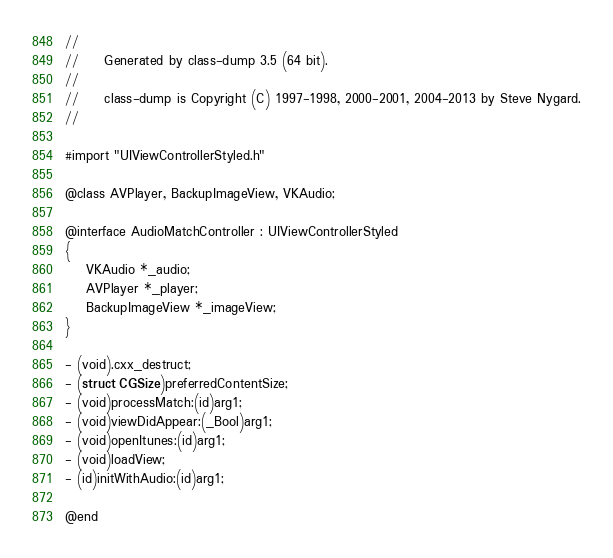Convert code to text. <code><loc_0><loc_0><loc_500><loc_500><_C_>//
//     Generated by class-dump 3.5 (64 bit).
//
//     class-dump is Copyright (C) 1997-1998, 2000-2001, 2004-2013 by Steve Nygard.
//

#import "UIViewControllerStyled.h"

@class AVPlayer, BackupImageView, VKAudio;

@interface AudioMatchController : UIViewControllerStyled
{
    VKAudio *_audio;
    AVPlayer *_player;
    BackupImageView *_imageView;
}

- (void).cxx_destruct;
- (struct CGSize)preferredContentSize;
- (void)processMatch:(id)arg1;
- (void)viewDidAppear:(_Bool)arg1;
- (void)openItunes:(id)arg1;
- (void)loadView;
- (id)initWithAudio:(id)arg1;

@end

</code> 